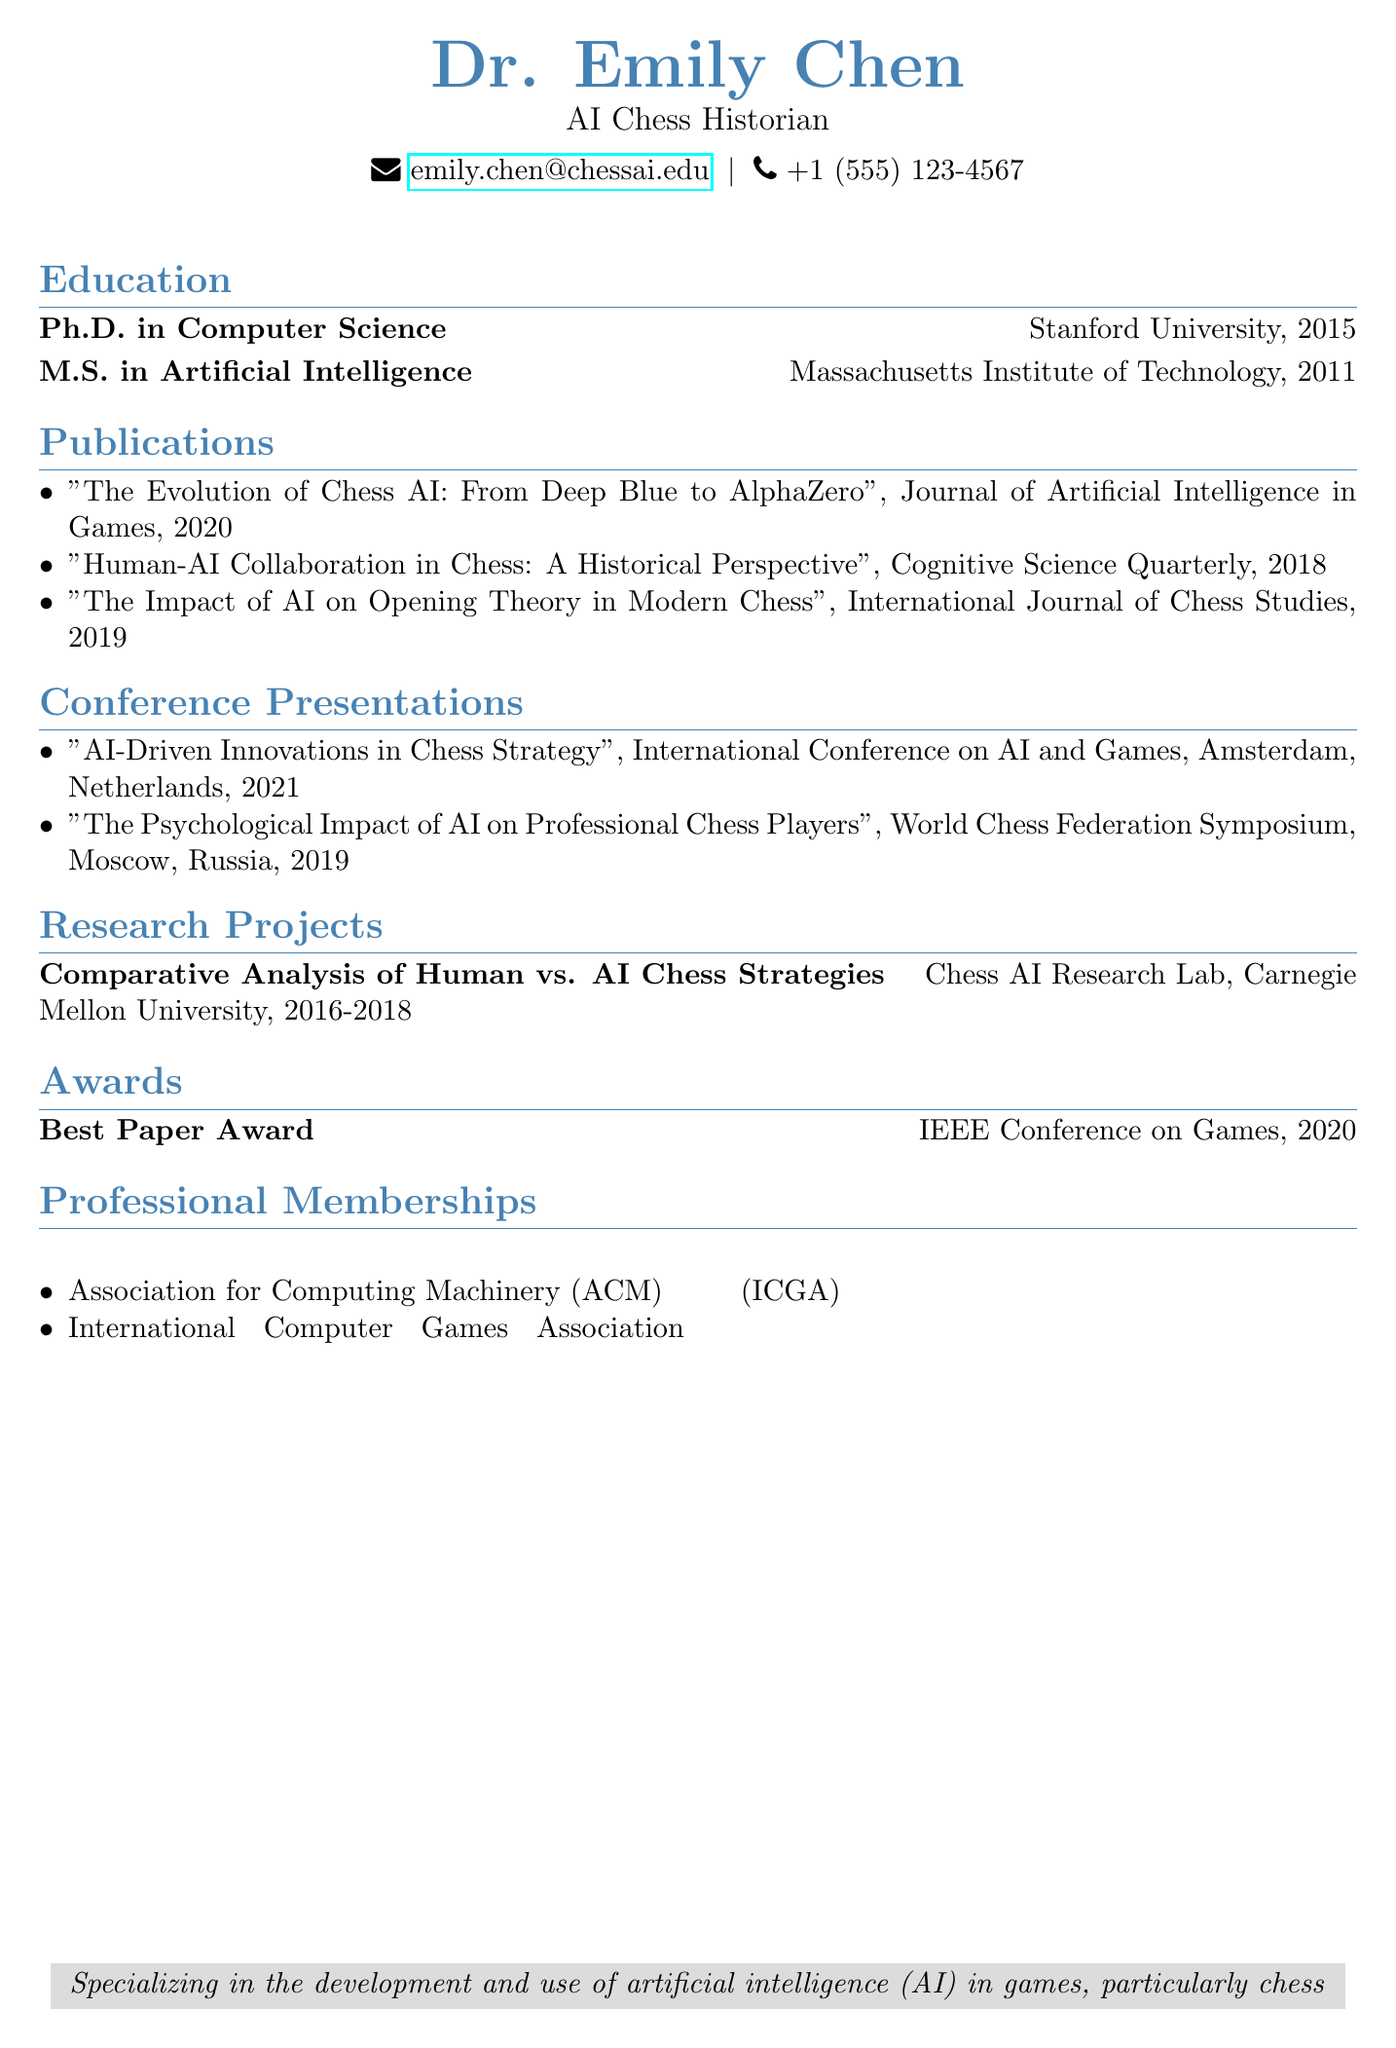what is the name of the historian? The name of the historian is prominently displayed at the top of the CV.
Answer: Dr. Emily Chen what is the title of the historian? The title is listed right below the name in the document.
Answer: AI Chess Historian which institution did the historian receive their Ph.D. from? The institution where the Ph.D. was earned is mentioned in the education section.
Answer: Stanford University what year was the publication "The Evolution of Chess AI: From Deep Blue to AlphaZero" released? The year of the publication is included next to the title in the publications section.
Answer: 2020 how many research projects are listed in the document? The number of research projects is determined by counting the entries in the research projects section.
Answer: 1 what conference did the historian present at in 2021? The conference name for the presentation in 2021 can be found in the conference presentations section.
Answer: International Conference on AI and Games which award did the historian receive in 2020? The award title is found in the awards section along with the year.
Answer: Best Paper Award what is the relationship between AI and chess according to the historian's focus? The specialization mentioned at the bottom provides context for the historian’s work.
Answer: Development and use of artificial intelligence (AI) in games, particularly chess how many publications are listed in the CV? Counting the entries in the publications section reveals the total.
Answer: 3 